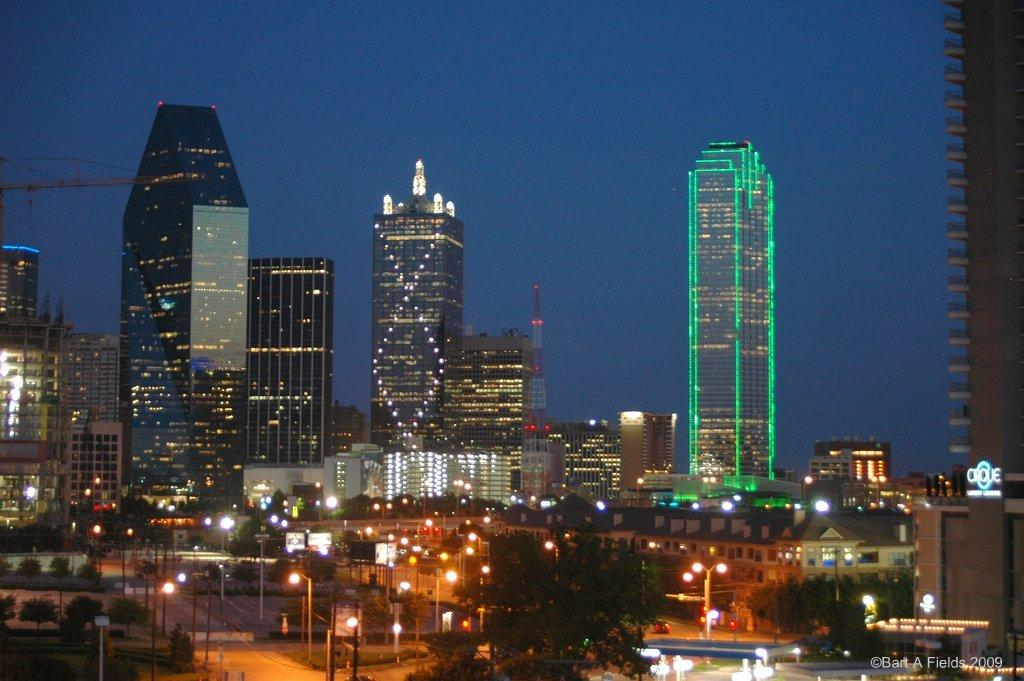What type of structures can be seen in the image? There are buildings and towers in the image. What are some other objects visible in the image? There are lights, poles, boards, trees, and vehicles on the road in the image. What is present at the bottom of the image? There is text at the bottom of the image. What can be seen at the top of the image? There is sky visible at the top of the image. Is there an earthquake happening in the image? No, there is no indication of an earthquake in the image. What company is responsible for the vehicles on the road in the image? The image does not provide information about the company responsible for the vehicles. 